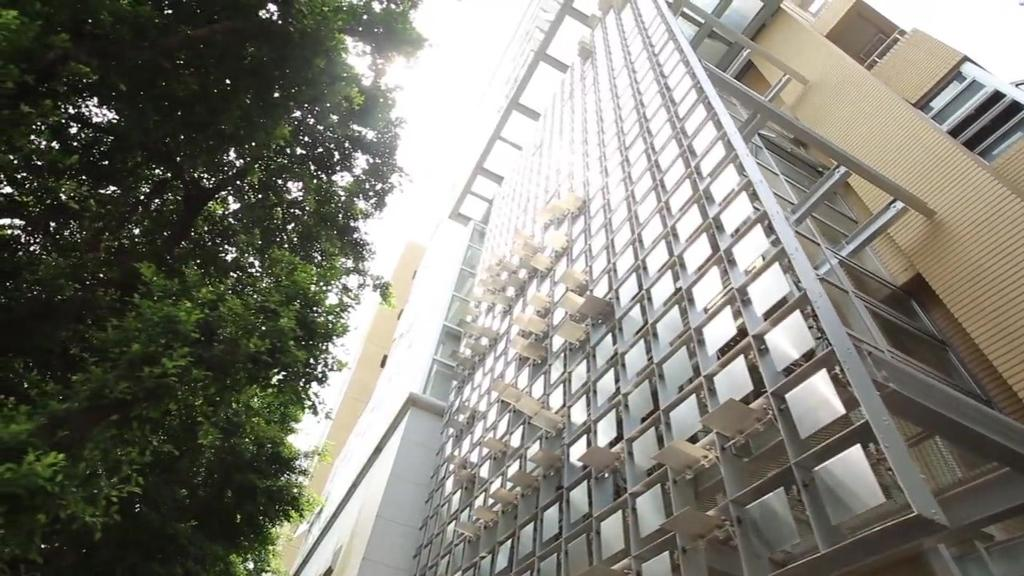What type of structure is present in the image? There is a building in the image. What type of vegetation is visible in the image? There is a tree in the image. What is visible in the sky in the image? The sky appears to be white in color, but this might be a transcription error. How many passengers are visible in the image? There are no passengers present in the image. What type of tiger can be seen climbing the tree in the image? There is no tiger present in the image, and therefore no such activity can be observed. 